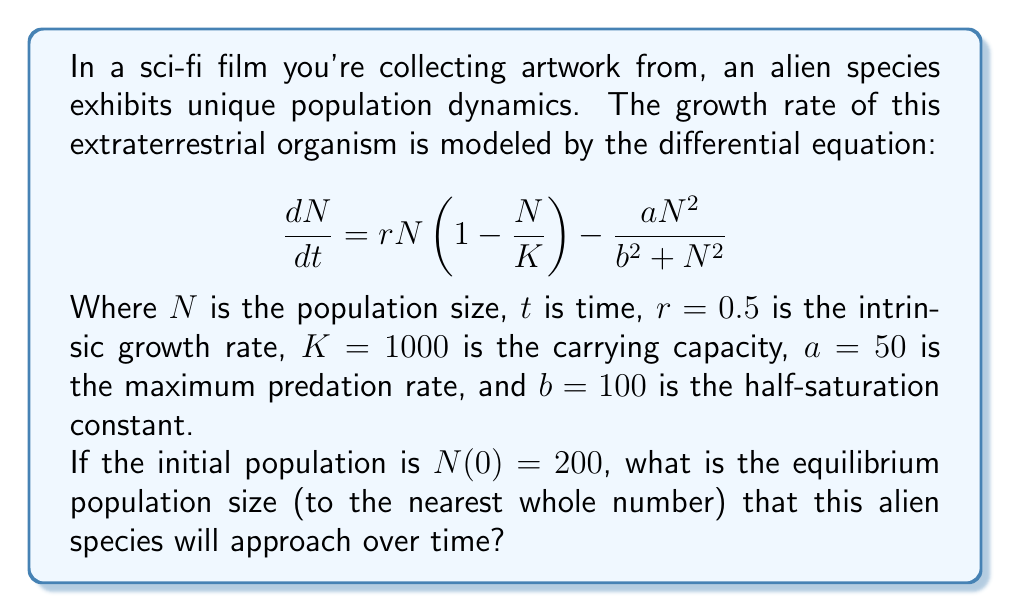Can you answer this question? To find the equilibrium population size, we need to set the rate of change equal to zero and solve for $N$. This gives us:

$$0 = rN\left(1 - \frac{N}{K}\right) - \frac{aN^2}{b^2 + N^2}$$

Substituting the given values:

$$0 = 0.5N\left(1 - \frac{N}{1000}\right) - \frac{50N^2}{100^2 + N^2}$$

Multiplying both sides by $(100^2 + N^2)$:

$$0 = 0.5N(1 - \frac{N}{1000})(100^2 + N^2) - 50N^2$$

Expanding:

$$0 = 0.5N(100^2 + N^2) - 0.5N^2(100^2 + N^2)/1000 - 50N^2$$

$$0 = 5000N + 0.5N^3 - 5N^2 - 0.0005N^4 - 50N^2$$

$$0 = 5000N + 0.5N^3 - 55N^2 - 0.0005N^4$$

This equation is difficult to solve analytically. We can use numerical methods to find the equilibrium points. Using a computer algebra system or numerical solver, we find that there are three equilibrium points:

1. $N \approx 0$ (unstable)
2. $N \approx 303.97$ (stable)
3. $N \approx 955.03$ (unstable)

The stable equilibrium point is the one we're interested in, as it's the population size that the species will approach over time.

Rounding to the nearest whole number, we get 304.
Answer: 304 